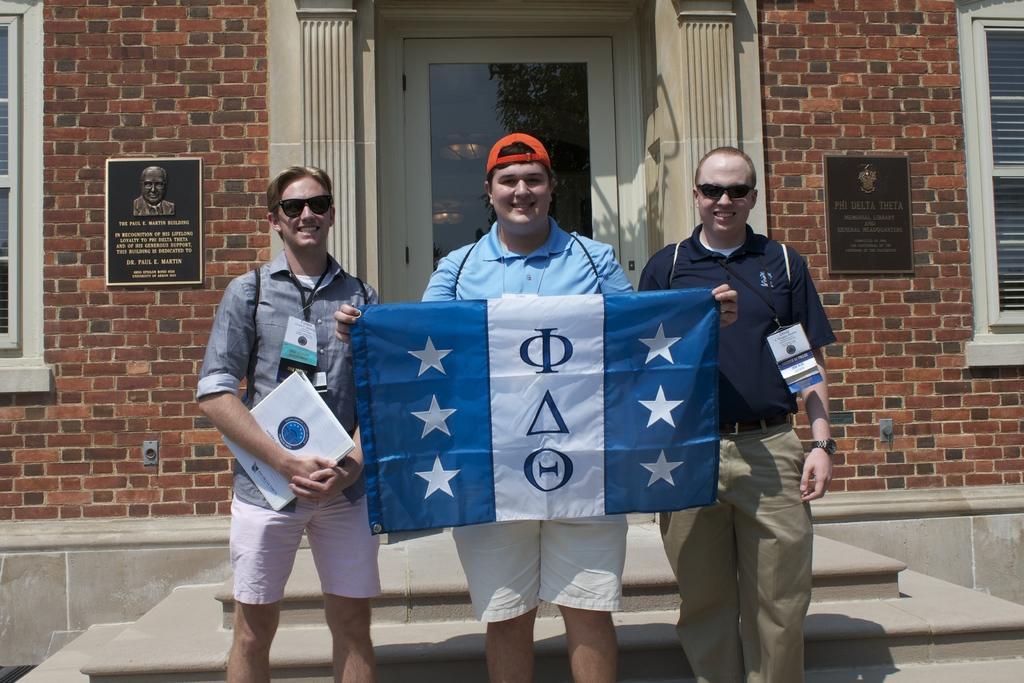Can you describe this image briefly? A person is holding book another person is holding cloth, this is well with the door. 